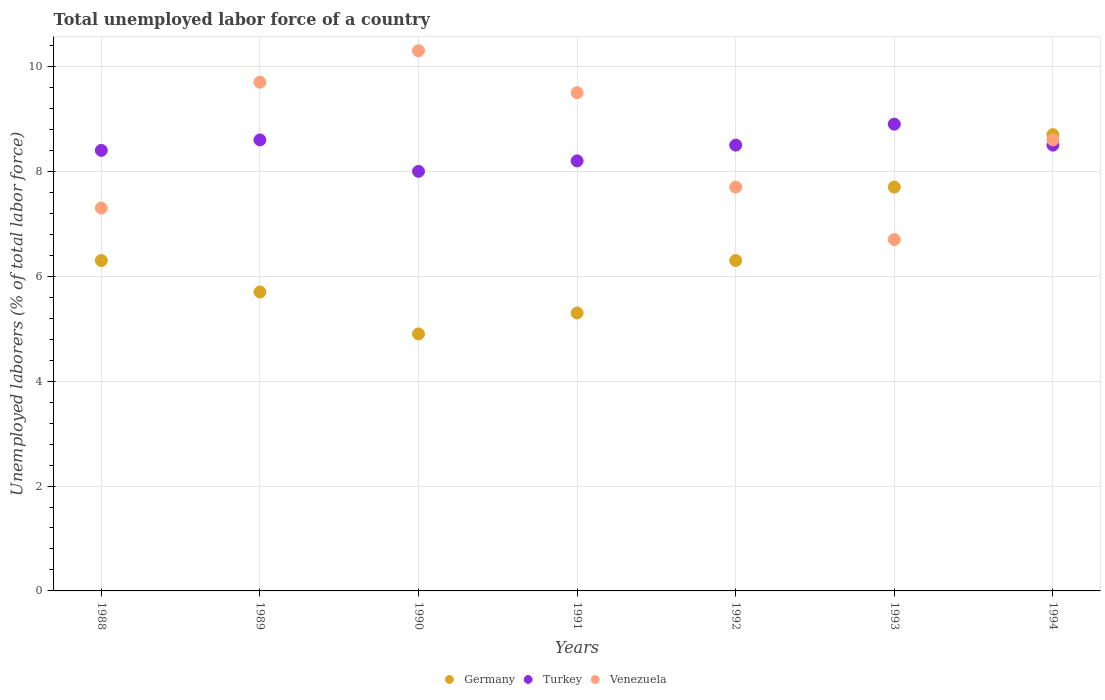How many different coloured dotlines are there?
Offer a very short reply. 3. What is the total unemployed labor force in Turkey in 1988?
Offer a very short reply. 8.4. Across all years, what is the maximum total unemployed labor force in Germany?
Your response must be concise. 8.7. Across all years, what is the minimum total unemployed labor force in Venezuela?
Your response must be concise. 6.7. In which year was the total unemployed labor force in Turkey maximum?
Offer a very short reply. 1993. In which year was the total unemployed labor force in Venezuela minimum?
Keep it short and to the point. 1993. What is the total total unemployed labor force in Venezuela in the graph?
Ensure brevity in your answer.  59.8. What is the difference between the total unemployed labor force in Venezuela in 1990 and that in 1994?
Give a very brief answer. 1.7. What is the difference between the total unemployed labor force in Venezuela in 1993 and the total unemployed labor force in Turkey in 1991?
Give a very brief answer. -1.5. What is the average total unemployed labor force in Turkey per year?
Provide a succinct answer. 8.44. In the year 1990, what is the difference between the total unemployed labor force in Germany and total unemployed labor force in Venezuela?
Provide a succinct answer. -5.4. In how many years, is the total unemployed labor force in Venezuela greater than 5.2 %?
Offer a very short reply. 7. What is the ratio of the total unemployed labor force in Turkey in 1988 to that in 1991?
Keep it short and to the point. 1.02. What is the difference between the highest and the second highest total unemployed labor force in Germany?
Make the answer very short. 1. What is the difference between the highest and the lowest total unemployed labor force in Turkey?
Your answer should be very brief. 0.9. Is it the case that in every year, the sum of the total unemployed labor force in Turkey and total unemployed labor force in Germany  is greater than the total unemployed labor force in Venezuela?
Provide a short and direct response. Yes. Does the total unemployed labor force in Germany monotonically increase over the years?
Make the answer very short. No. Is the total unemployed labor force in Turkey strictly less than the total unemployed labor force in Germany over the years?
Provide a succinct answer. No. What is the difference between two consecutive major ticks on the Y-axis?
Make the answer very short. 2. Are the values on the major ticks of Y-axis written in scientific E-notation?
Give a very brief answer. No. Does the graph contain any zero values?
Make the answer very short. No. Does the graph contain grids?
Provide a succinct answer. Yes. What is the title of the graph?
Provide a short and direct response. Total unemployed labor force of a country. Does "Haiti" appear as one of the legend labels in the graph?
Your answer should be very brief. No. What is the label or title of the Y-axis?
Give a very brief answer. Unemployed laborers (% of total labor force). What is the Unemployed laborers (% of total labor force) in Germany in 1988?
Provide a succinct answer. 6.3. What is the Unemployed laborers (% of total labor force) of Turkey in 1988?
Your answer should be compact. 8.4. What is the Unemployed laborers (% of total labor force) in Venezuela in 1988?
Keep it short and to the point. 7.3. What is the Unemployed laborers (% of total labor force) of Germany in 1989?
Make the answer very short. 5.7. What is the Unemployed laborers (% of total labor force) of Turkey in 1989?
Give a very brief answer. 8.6. What is the Unemployed laborers (% of total labor force) in Venezuela in 1989?
Your answer should be compact. 9.7. What is the Unemployed laborers (% of total labor force) in Germany in 1990?
Provide a succinct answer. 4.9. What is the Unemployed laborers (% of total labor force) of Venezuela in 1990?
Give a very brief answer. 10.3. What is the Unemployed laborers (% of total labor force) of Germany in 1991?
Provide a succinct answer. 5.3. What is the Unemployed laborers (% of total labor force) of Turkey in 1991?
Give a very brief answer. 8.2. What is the Unemployed laborers (% of total labor force) in Germany in 1992?
Your answer should be very brief. 6.3. What is the Unemployed laborers (% of total labor force) in Venezuela in 1992?
Offer a terse response. 7.7. What is the Unemployed laborers (% of total labor force) in Germany in 1993?
Your response must be concise. 7.7. What is the Unemployed laborers (% of total labor force) of Turkey in 1993?
Provide a short and direct response. 8.9. What is the Unemployed laborers (% of total labor force) of Venezuela in 1993?
Provide a succinct answer. 6.7. What is the Unemployed laborers (% of total labor force) in Germany in 1994?
Your answer should be compact. 8.7. What is the Unemployed laborers (% of total labor force) in Venezuela in 1994?
Offer a very short reply. 8.6. Across all years, what is the maximum Unemployed laborers (% of total labor force) of Germany?
Provide a short and direct response. 8.7. Across all years, what is the maximum Unemployed laborers (% of total labor force) in Turkey?
Offer a terse response. 8.9. Across all years, what is the maximum Unemployed laborers (% of total labor force) of Venezuela?
Ensure brevity in your answer.  10.3. Across all years, what is the minimum Unemployed laborers (% of total labor force) in Germany?
Offer a very short reply. 4.9. Across all years, what is the minimum Unemployed laborers (% of total labor force) of Venezuela?
Provide a succinct answer. 6.7. What is the total Unemployed laborers (% of total labor force) in Germany in the graph?
Your answer should be very brief. 44.9. What is the total Unemployed laborers (% of total labor force) in Turkey in the graph?
Your response must be concise. 59.1. What is the total Unemployed laborers (% of total labor force) in Venezuela in the graph?
Offer a terse response. 59.8. What is the difference between the Unemployed laborers (% of total labor force) in Turkey in 1988 and that in 1989?
Keep it short and to the point. -0.2. What is the difference between the Unemployed laborers (% of total labor force) in Turkey in 1988 and that in 1990?
Your answer should be very brief. 0.4. What is the difference between the Unemployed laborers (% of total labor force) of Venezuela in 1988 and that in 1990?
Your answer should be very brief. -3. What is the difference between the Unemployed laborers (% of total labor force) in Germany in 1988 and that in 1991?
Your response must be concise. 1. What is the difference between the Unemployed laborers (% of total labor force) of Turkey in 1988 and that in 1992?
Make the answer very short. -0.1. What is the difference between the Unemployed laborers (% of total labor force) in Venezuela in 1988 and that in 1993?
Give a very brief answer. 0.6. What is the difference between the Unemployed laborers (% of total labor force) in Venezuela in 1988 and that in 1994?
Your response must be concise. -1.3. What is the difference between the Unemployed laborers (% of total labor force) of Germany in 1989 and that in 1990?
Your answer should be compact. 0.8. What is the difference between the Unemployed laborers (% of total labor force) of Venezuela in 1989 and that in 1990?
Your answer should be very brief. -0.6. What is the difference between the Unemployed laborers (% of total labor force) of Germany in 1989 and that in 1991?
Your answer should be very brief. 0.4. What is the difference between the Unemployed laborers (% of total labor force) in Turkey in 1989 and that in 1992?
Keep it short and to the point. 0.1. What is the difference between the Unemployed laborers (% of total labor force) in Venezuela in 1989 and that in 1992?
Offer a very short reply. 2. What is the difference between the Unemployed laborers (% of total labor force) in Turkey in 1989 and that in 1993?
Provide a short and direct response. -0.3. What is the difference between the Unemployed laborers (% of total labor force) of Venezuela in 1989 and that in 1993?
Offer a terse response. 3. What is the difference between the Unemployed laborers (% of total labor force) in Turkey in 1989 and that in 1994?
Offer a very short reply. 0.1. What is the difference between the Unemployed laborers (% of total labor force) of Germany in 1990 and that in 1991?
Ensure brevity in your answer.  -0.4. What is the difference between the Unemployed laborers (% of total labor force) in Turkey in 1990 and that in 1991?
Make the answer very short. -0.2. What is the difference between the Unemployed laborers (% of total labor force) of Venezuela in 1990 and that in 1991?
Make the answer very short. 0.8. What is the difference between the Unemployed laborers (% of total labor force) in Turkey in 1990 and that in 1992?
Make the answer very short. -0.5. What is the difference between the Unemployed laborers (% of total labor force) in Venezuela in 1990 and that in 1992?
Offer a terse response. 2.6. What is the difference between the Unemployed laborers (% of total labor force) of Germany in 1990 and that in 1994?
Make the answer very short. -3.8. What is the difference between the Unemployed laborers (% of total labor force) of Venezuela in 1990 and that in 1994?
Your answer should be very brief. 1.7. What is the difference between the Unemployed laborers (% of total labor force) of Turkey in 1991 and that in 1992?
Keep it short and to the point. -0.3. What is the difference between the Unemployed laborers (% of total labor force) of Venezuela in 1991 and that in 1992?
Make the answer very short. 1.8. What is the difference between the Unemployed laborers (% of total labor force) of Turkey in 1991 and that in 1994?
Offer a terse response. -0.3. What is the difference between the Unemployed laborers (% of total labor force) in Venezuela in 1991 and that in 1994?
Provide a short and direct response. 0.9. What is the difference between the Unemployed laborers (% of total labor force) in Venezuela in 1992 and that in 1993?
Provide a succinct answer. 1. What is the difference between the Unemployed laborers (% of total labor force) of Turkey in 1992 and that in 1994?
Provide a succinct answer. 0. What is the difference between the Unemployed laborers (% of total labor force) of Germany in 1993 and that in 1994?
Offer a very short reply. -1. What is the difference between the Unemployed laborers (% of total labor force) in Turkey in 1993 and that in 1994?
Keep it short and to the point. 0.4. What is the difference between the Unemployed laborers (% of total labor force) of Venezuela in 1993 and that in 1994?
Offer a very short reply. -1.9. What is the difference between the Unemployed laborers (% of total labor force) of Turkey in 1988 and the Unemployed laborers (% of total labor force) of Venezuela in 1989?
Keep it short and to the point. -1.3. What is the difference between the Unemployed laborers (% of total labor force) in Germany in 1988 and the Unemployed laborers (% of total labor force) in Turkey in 1990?
Your answer should be compact. -1.7. What is the difference between the Unemployed laborers (% of total labor force) of Turkey in 1988 and the Unemployed laborers (% of total labor force) of Venezuela in 1990?
Your answer should be compact. -1.9. What is the difference between the Unemployed laborers (% of total labor force) in Germany in 1988 and the Unemployed laborers (% of total labor force) in Turkey in 1991?
Ensure brevity in your answer.  -1.9. What is the difference between the Unemployed laborers (% of total labor force) in Turkey in 1988 and the Unemployed laborers (% of total labor force) in Venezuela in 1991?
Offer a terse response. -1.1. What is the difference between the Unemployed laborers (% of total labor force) of Germany in 1988 and the Unemployed laborers (% of total labor force) of Turkey in 1993?
Your response must be concise. -2.6. What is the difference between the Unemployed laborers (% of total labor force) in Germany in 1988 and the Unemployed laborers (% of total labor force) in Venezuela in 1993?
Ensure brevity in your answer.  -0.4. What is the difference between the Unemployed laborers (% of total labor force) in Turkey in 1988 and the Unemployed laborers (% of total labor force) in Venezuela in 1993?
Offer a terse response. 1.7. What is the difference between the Unemployed laborers (% of total labor force) in Germany in 1988 and the Unemployed laborers (% of total labor force) in Venezuela in 1994?
Ensure brevity in your answer.  -2.3. What is the difference between the Unemployed laborers (% of total labor force) of Germany in 1989 and the Unemployed laborers (% of total labor force) of Venezuela in 1990?
Make the answer very short. -4.6. What is the difference between the Unemployed laborers (% of total labor force) in Turkey in 1989 and the Unemployed laborers (% of total labor force) in Venezuela in 1990?
Your answer should be very brief. -1.7. What is the difference between the Unemployed laborers (% of total labor force) in Germany in 1989 and the Unemployed laborers (% of total labor force) in Turkey in 1992?
Offer a very short reply. -2.8. What is the difference between the Unemployed laborers (% of total labor force) of Germany in 1989 and the Unemployed laborers (% of total labor force) of Venezuela in 1992?
Provide a short and direct response. -2. What is the difference between the Unemployed laborers (% of total labor force) of Germany in 1989 and the Unemployed laborers (% of total labor force) of Venezuela in 1993?
Offer a terse response. -1. What is the difference between the Unemployed laborers (% of total labor force) of Turkey in 1989 and the Unemployed laborers (% of total labor force) of Venezuela in 1993?
Provide a short and direct response. 1.9. What is the difference between the Unemployed laborers (% of total labor force) of Germany in 1989 and the Unemployed laborers (% of total labor force) of Venezuela in 1994?
Your answer should be compact. -2.9. What is the difference between the Unemployed laborers (% of total labor force) in Germany in 1990 and the Unemployed laborers (% of total labor force) in Turkey in 1991?
Offer a terse response. -3.3. What is the difference between the Unemployed laborers (% of total labor force) in Germany in 1990 and the Unemployed laborers (% of total labor force) in Venezuela in 1991?
Provide a short and direct response. -4.6. What is the difference between the Unemployed laborers (% of total labor force) in Germany in 1990 and the Unemployed laborers (% of total labor force) in Turkey in 1992?
Offer a terse response. -3.6. What is the difference between the Unemployed laborers (% of total labor force) of Germany in 1990 and the Unemployed laborers (% of total labor force) of Venezuela in 1992?
Provide a short and direct response. -2.8. What is the difference between the Unemployed laborers (% of total labor force) in Turkey in 1990 and the Unemployed laborers (% of total labor force) in Venezuela in 1992?
Give a very brief answer. 0.3. What is the difference between the Unemployed laborers (% of total labor force) in Germany in 1990 and the Unemployed laborers (% of total labor force) in Turkey in 1993?
Give a very brief answer. -4. What is the difference between the Unemployed laborers (% of total labor force) of Germany in 1990 and the Unemployed laborers (% of total labor force) of Venezuela in 1993?
Ensure brevity in your answer.  -1.8. What is the difference between the Unemployed laborers (% of total labor force) of Germany in 1990 and the Unemployed laborers (% of total labor force) of Turkey in 1994?
Offer a terse response. -3.6. What is the difference between the Unemployed laborers (% of total labor force) in Germany in 1990 and the Unemployed laborers (% of total labor force) in Venezuela in 1994?
Offer a very short reply. -3.7. What is the difference between the Unemployed laborers (% of total labor force) of Turkey in 1991 and the Unemployed laborers (% of total labor force) of Venezuela in 1992?
Keep it short and to the point. 0.5. What is the difference between the Unemployed laborers (% of total labor force) of Germany in 1991 and the Unemployed laborers (% of total labor force) of Turkey in 1993?
Make the answer very short. -3.6. What is the difference between the Unemployed laborers (% of total labor force) in Germany in 1991 and the Unemployed laborers (% of total labor force) in Venezuela in 1993?
Your response must be concise. -1.4. What is the difference between the Unemployed laborers (% of total labor force) in Turkey in 1991 and the Unemployed laborers (% of total labor force) in Venezuela in 1993?
Give a very brief answer. 1.5. What is the difference between the Unemployed laborers (% of total labor force) of Germany in 1991 and the Unemployed laborers (% of total labor force) of Venezuela in 1994?
Offer a terse response. -3.3. What is the difference between the Unemployed laborers (% of total labor force) of Turkey in 1991 and the Unemployed laborers (% of total labor force) of Venezuela in 1994?
Make the answer very short. -0.4. What is the difference between the Unemployed laborers (% of total labor force) in Germany in 1992 and the Unemployed laborers (% of total labor force) in Turkey in 1993?
Give a very brief answer. -2.6. What is the difference between the Unemployed laborers (% of total labor force) of Germany in 1992 and the Unemployed laborers (% of total labor force) of Venezuela in 1993?
Provide a succinct answer. -0.4. What is the difference between the Unemployed laborers (% of total labor force) in Turkey in 1992 and the Unemployed laborers (% of total labor force) in Venezuela in 1993?
Keep it short and to the point. 1.8. What is the difference between the Unemployed laborers (% of total labor force) of Turkey in 1992 and the Unemployed laborers (% of total labor force) of Venezuela in 1994?
Offer a terse response. -0.1. What is the difference between the Unemployed laborers (% of total labor force) in Turkey in 1993 and the Unemployed laborers (% of total labor force) in Venezuela in 1994?
Your answer should be very brief. 0.3. What is the average Unemployed laborers (% of total labor force) in Germany per year?
Your answer should be very brief. 6.41. What is the average Unemployed laborers (% of total labor force) of Turkey per year?
Make the answer very short. 8.44. What is the average Unemployed laborers (% of total labor force) in Venezuela per year?
Make the answer very short. 8.54. In the year 1988, what is the difference between the Unemployed laborers (% of total labor force) in Germany and Unemployed laborers (% of total labor force) in Turkey?
Your response must be concise. -2.1. In the year 1988, what is the difference between the Unemployed laborers (% of total labor force) in Germany and Unemployed laborers (% of total labor force) in Venezuela?
Make the answer very short. -1. In the year 1988, what is the difference between the Unemployed laborers (% of total labor force) in Turkey and Unemployed laborers (% of total labor force) in Venezuela?
Give a very brief answer. 1.1. In the year 1989, what is the difference between the Unemployed laborers (% of total labor force) in Germany and Unemployed laborers (% of total labor force) in Turkey?
Make the answer very short. -2.9. In the year 1989, what is the difference between the Unemployed laborers (% of total labor force) in Turkey and Unemployed laborers (% of total labor force) in Venezuela?
Provide a succinct answer. -1.1. In the year 1990, what is the difference between the Unemployed laborers (% of total labor force) of Turkey and Unemployed laborers (% of total labor force) of Venezuela?
Provide a succinct answer. -2.3. In the year 1991, what is the difference between the Unemployed laborers (% of total labor force) in Germany and Unemployed laborers (% of total labor force) in Turkey?
Offer a terse response. -2.9. In the year 1991, what is the difference between the Unemployed laborers (% of total labor force) of Germany and Unemployed laborers (% of total labor force) of Venezuela?
Offer a terse response. -4.2. In the year 1993, what is the difference between the Unemployed laborers (% of total labor force) of Germany and Unemployed laborers (% of total labor force) of Venezuela?
Give a very brief answer. 1. In the year 1994, what is the difference between the Unemployed laborers (% of total labor force) of Germany and Unemployed laborers (% of total labor force) of Turkey?
Your response must be concise. 0.2. In the year 1994, what is the difference between the Unemployed laborers (% of total labor force) of Germany and Unemployed laborers (% of total labor force) of Venezuela?
Offer a very short reply. 0.1. In the year 1994, what is the difference between the Unemployed laborers (% of total labor force) of Turkey and Unemployed laborers (% of total labor force) of Venezuela?
Your answer should be very brief. -0.1. What is the ratio of the Unemployed laborers (% of total labor force) of Germany in 1988 to that in 1989?
Provide a short and direct response. 1.11. What is the ratio of the Unemployed laborers (% of total labor force) in Turkey in 1988 to that in 1989?
Your answer should be very brief. 0.98. What is the ratio of the Unemployed laborers (% of total labor force) of Venezuela in 1988 to that in 1989?
Give a very brief answer. 0.75. What is the ratio of the Unemployed laborers (% of total labor force) in Venezuela in 1988 to that in 1990?
Your answer should be compact. 0.71. What is the ratio of the Unemployed laborers (% of total labor force) of Germany in 1988 to that in 1991?
Ensure brevity in your answer.  1.19. What is the ratio of the Unemployed laborers (% of total labor force) of Turkey in 1988 to that in 1991?
Your answer should be compact. 1.02. What is the ratio of the Unemployed laborers (% of total labor force) of Venezuela in 1988 to that in 1991?
Provide a succinct answer. 0.77. What is the ratio of the Unemployed laborers (% of total labor force) in Germany in 1988 to that in 1992?
Provide a succinct answer. 1. What is the ratio of the Unemployed laborers (% of total labor force) in Turkey in 1988 to that in 1992?
Give a very brief answer. 0.99. What is the ratio of the Unemployed laborers (% of total labor force) of Venezuela in 1988 to that in 1992?
Provide a succinct answer. 0.95. What is the ratio of the Unemployed laborers (% of total labor force) of Germany in 1988 to that in 1993?
Keep it short and to the point. 0.82. What is the ratio of the Unemployed laborers (% of total labor force) of Turkey in 1988 to that in 1993?
Ensure brevity in your answer.  0.94. What is the ratio of the Unemployed laborers (% of total labor force) in Venezuela in 1988 to that in 1993?
Ensure brevity in your answer.  1.09. What is the ratio of the Unemployed laborers (% of total labor force) of Germany in 1988 to that in 1994?
Offer a terse response. 0.72. What is the ratio of the Unemployed laborers (% of total labor force) of Venezuela in 1988 to that in 1994?
Offer a terse response. 0.85. What is the ratio of the Unemployed laborers (% of total labor force) in Germany in 1989 to that in 1990?
Give a very brief answer. 1.16. What is the ratio of the Unemployed laborers (% of total labor force) of Turkey in 1989 to that in 1990?
Provide a succinct answer. 1.07. What is the ratio of the Unemployed laborers (% of total labor force) of Venezuela in 1989 to that in 1990?
Give a very brief answer. 0.94. What is the ratio of the Unemployed laborers (% of total labor force) of Germany in 1989 to that in 1991?
Offer a terse response. 1.08. What is the ratio of the Unemployed laborers (% of total labor force) of Turkey in 1989 to that in 1991?
Your answer should be very brief. 1.05. What is the ratio of the Unemployed laborers (% of total labor force) in Venezuela in 1989 to that in 1991?
Make the answer very short. 1.02. What is the ratio of the Unemployed laborers (% of total labor force) in Germany in 1989 to that in 1992?
Your answer should be very brief. 0.9. What is the ratio of the Unemployed laborers (% of total labor force) of Turkey in 1989 to that in 1992?
Keep it short and to the point. 1.01. What is the ratio of the Unemployed laborers (% of total labor force) in Venezuela in 1989 to that in 1992?
Offer a very short reply. 1.26. What is the ratio of the Unemployed laborers (% of total labor force) in Germany in 1989 to that in 1993?
Your answer should be compact. 0.74. What is the ratio of the Unemployed laborers (% of total labor force) of Turkey in 1989 to that in 1993?
Your answer should be compact. 0.97. What is the ratio of the Unemployed laborers (% of total labor force) in Venezuela in 1989 to that in 1993?
Give a very brief answer. 1.45. What is the ratio of the Unemployed laborers (% of total labor force) of Germany in 1989 to that in 1994?
Provide a short and direct response. 0.66. What is the ratio of the Unemployed laborers (% of total labor force) in Turkey in 1989 to that in 1994?
Make the answer very short. 1.01. What is the ratio of the Unemployed laborers (% of total labor force) in Venezuela in 1989 to that in 1994?
Give a very brief answer. 1.13. What is the ratio of the Unemployed laborers (% of total labor force) of Germany in 1990 to that in 1991?
Ensure brevity in your answer.  0.92. What is the ratio of the Unemployed laborers (% of total labor force) in Turkey in 1990 to that in 1991?
Your response must be concise. 0.98. What is the ratio of the Unemployed laborers (% of total labor force) in Venezuela in 1990 to that in 1991?
Your answer should be very brief. 1.08. What is the ratio of the Unemployed laborers (% of total labor force) in Turkey in 1990 to that in 1992?
Offer a terse response. 0.94. What is the ratio of the Unemployed laborers (% of total labor force) of Venezuela in 1990 to that in 1992?
Keep it short and to the point. 1.34. What is the ratio of the Unemployed laborers (% of total labor force) in Germany in 1990 to that in 1993?
Provide a succinct answer. 0.64. What is the ratio of the Unemployed laborers (% of total labor force) in Turkey in 1990 to that in 1993?
Your response must be concise. 0.9. What is the ratio of the Unemployed laborers (% of total labor force) in Venezuela in 1990 to that in 1993?
Offer a terse response. 1.54. What is the ratio of the Unemployed laborers (% of total labor force) in Germany in 1990 to that in 1994?
Offer a very short reply. 0.56. What is the ratio of the Unemployed laborers (% of total labor force) in Venezuela in 1990 to that in 1994?
Keep it short and to the point. 1.2. What is the ratio of the Unemployed laborers (% of total labor force) of Germany in 1991 to that in 1992?
Provide a succinct answer. 0.84. What is the ratio of the Unemployed laborers (% of total labor force) in Turkey in 1991 to that in 1992?
Offer a terse response. 0.96. What is the ratio of the Unemployed laborers (% of total labor force) of Venezuela in 1991 to that in 1992?
Your response must be concise. 1.23. What is the ratio of the Unemployed laborers (% of total labor force) in Germany in 1991 to that in 1993?
Make the answer very short. 0.69. What is the ratio of the Unemployed laborers (% of total labor force) of Turkey in 1991 to that in 1993?
Ensure brevity in your answer.  0.92. What is the ratio of the Unemployed laborers (% of total labor force) of Venezuela in 1991 to that in 1993?
Provide a succinct answer. 1.42. What is the ratio of the Unemployed laborers (% of total labor force) in Germany in 1991 to that in 1994?
Offer a terse response. 0.61. What is the ratio of the Unemployed laborers (% of total labor force) of Turkey in 1991 to that in 1994?
Keep it short and to the point. 0.96. What is the ratio of the Unemployed laborers (% of total labor force) of Venezuela in 1991 to that in 1994?
Your answer should be very brief. 1.1. What is the ratio of the Unemployed laborers (% of total labor force) of Germany in 1992 to that in 1993?
Offer a terse response. 0.82. What is the ratio of the Unemployed laborers (% of total labor force) in Turkey in 1992 to that in 1993?
Your answer should be very brief. 0.96. What is the ratio of the Unemployed laborers (% of total labor force) of Venezuela in 1992 to that in 1993?
Make the answer very short. 1.15. What is the ratio of the Unemployed laborers (% of total labor force) in Germany in 1992 to that in 1994?
Keep it short and to the point. 0.72. What is the ratio of the Unemployed laborers (% of total labor force) in Turkey in 1992 to that in 1994?
Make the answer very short. 1. What is the ratio of the Unemployed laborers (% of total labor force) of Venezuela in 1992 to that in 1994?
Offer a very short reply. 0.9. What is the ratio of the Unemployed laborers (% of total labor force) of Germany in 1993 to that in 1994?
Offer a very short reply. 0.89. What is the ratio of the Unemployed laborers (% of total labor force) in Turkey in 1993 to that in 1994?
Make the answer very short. 1.05. What is the ratio of the Unemployed laborers (% of total labor force) in Venezuela in 1993 to that in 1994?
Your answer should be very brief. 0.78. What is the difference between the highest and the second highest Unemployed laborers (% of total labor force) of Germany?
Offer a very short reply. 1. What is the difference between the highest and the second highest Unemployed laborers (% of total labor force) in Venezuela?
Offer a very short reply. 0.6. 